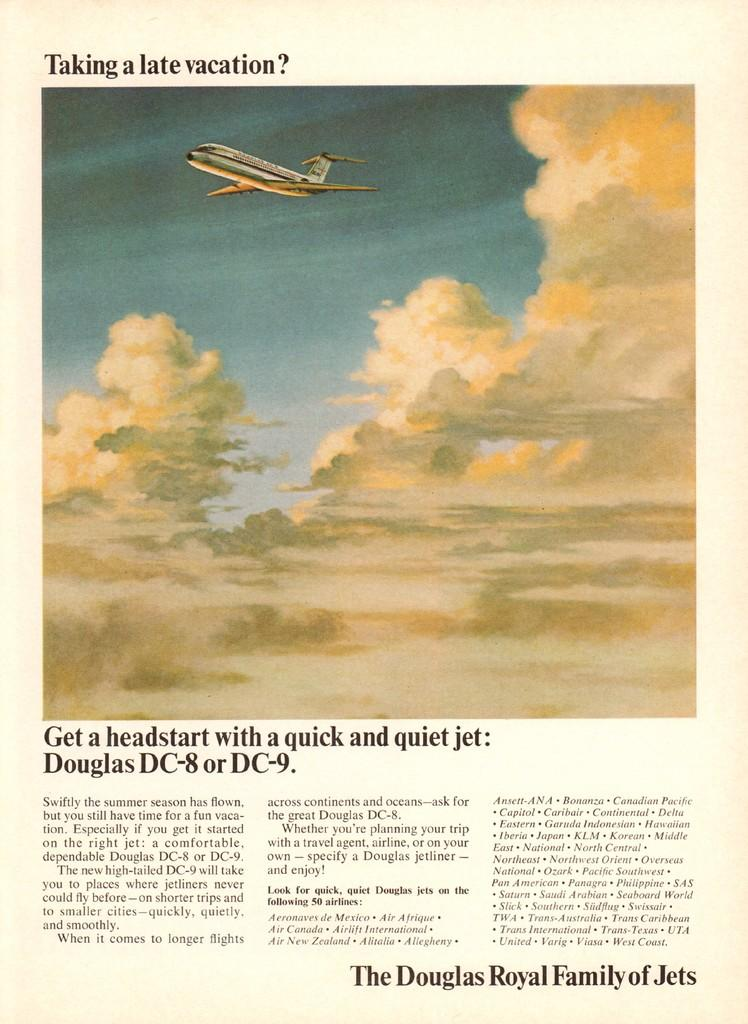What is featured on the poster in the image? The poster contains clouds and an airplane. What else can be seen on the poster besides the clouds and airplane? There is text written on the poster. What type of kettle is visible on the poster? There is no kettle present on the poster; it only contains clouds, an airplane, and text. How much payment is required to purchase the airplane depicted on the poster? There is no information about payment or purchasing the airplane on the poster, as it only contains clouds, an airplane, and text. 